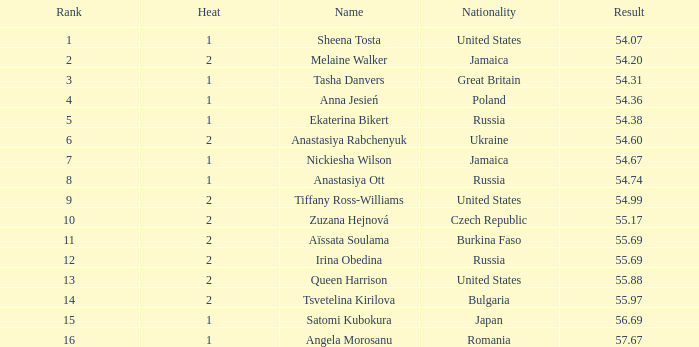Which Heat has a Nationality of bulgaria, and a Result larger than 55.97? None. 